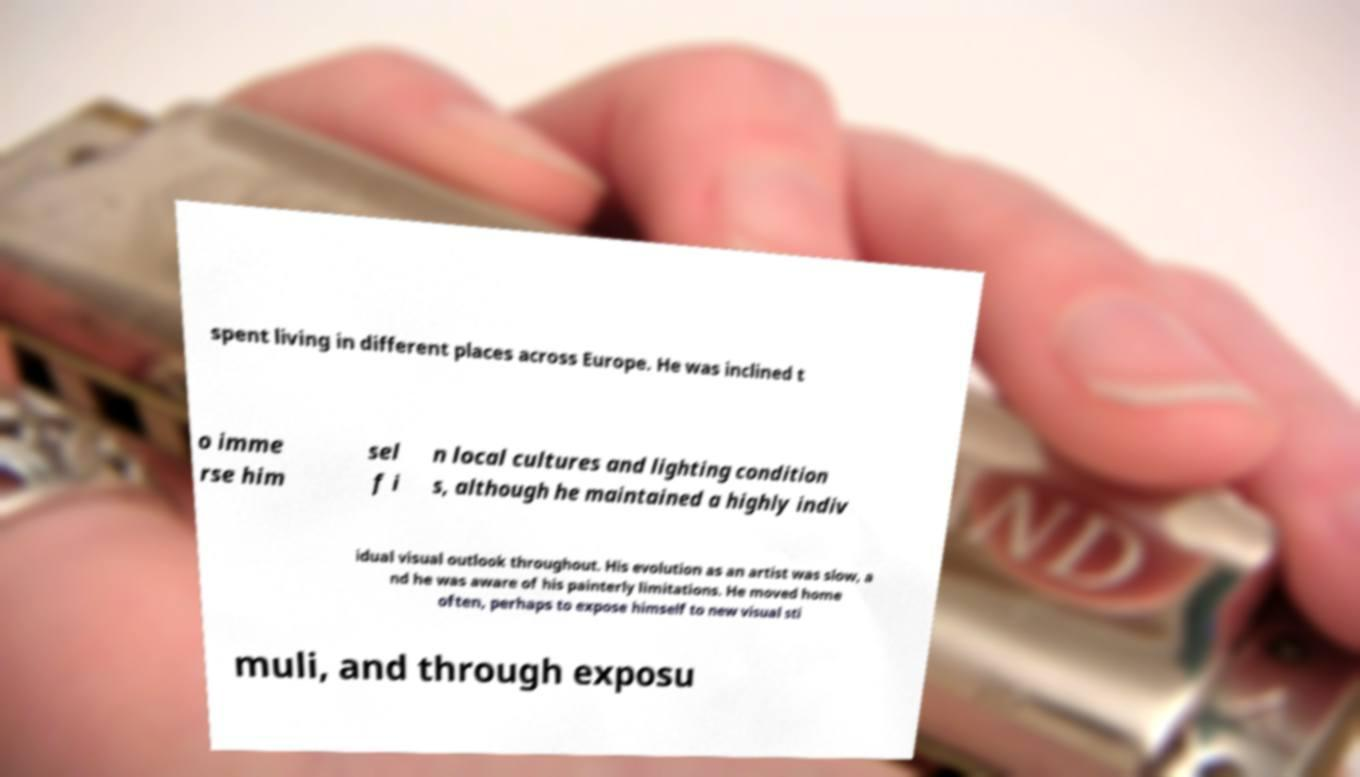Could you assist in decoding the text presented in this image and type it out clearly? spent living in different places across Europe. He was inclined t o imme rse him sel f i n local cultures and lighting condition s, although he maintained a highly indiv idual visual outlook throughout. His evolution as an artist was slow, a nd he was aware of his painterly limitations. He moved home often, perhaps to expose himself to new visual sti muli, and through exposu 